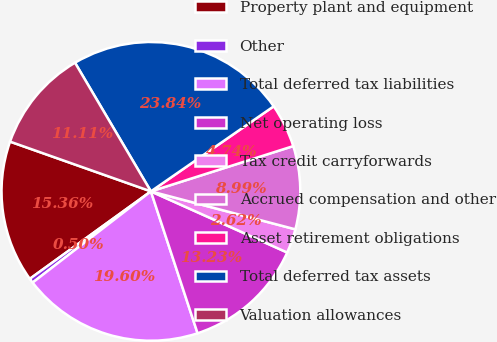<chart> <loc_0><loc_0><loc_500><loc_500><pie_chart><fcel>Property plant and equipment<fcel>Other<fcel>Total deferred tax liabilities<fcel>Net operating loss<fcel>Tax credit carryforwards<fcel>Accrued compensation and other<fcel>Asset retirement obligations<fcel>Total deferred tax assets<fcel>Valuation allowances<nl><fcel>15.36%<fcel>0.5%<fcel>19.6%<fcel>13.23%<fcel>2.62%<fcel>8.99%<fcel>4.74%<fcel>23.84%<fcel>11.11%<nl></chart> 